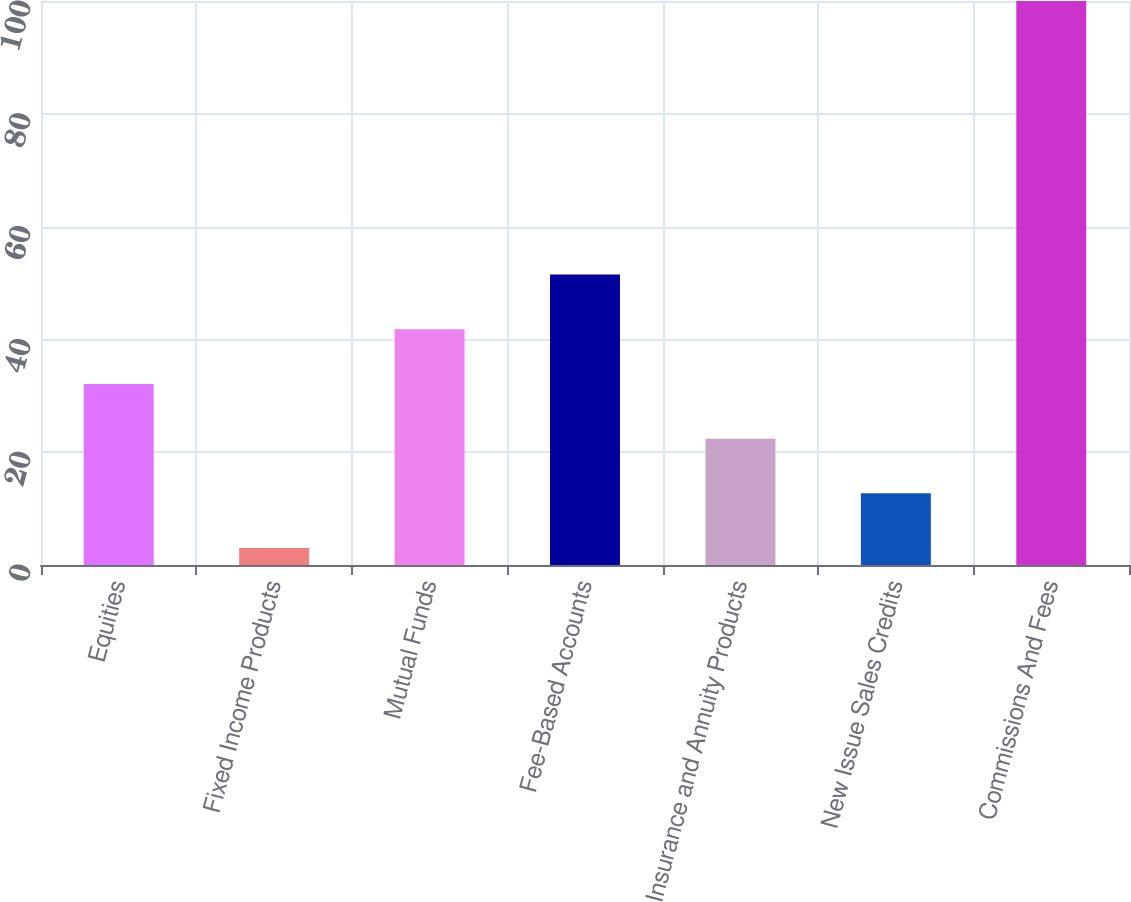Convert chart. <chart><loc_0><loc_0><loc_500><loc_500><bar_chart><fcel>Equities<fcel>Fixed Income Products<fcel>Mutual Funds<fcel>Fee-Based Accounts<fcel>Insurance and Annuity Products<fcel>New Issue Sales Credits<fcel>Commissions And Fees<nl><fcel>32.1<fcel>3<fcel>41.8<fcel>51.5<fcel>22.4<fcel>12.7<fcel>100<nl></chart> 